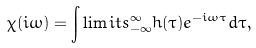<formula> <loc_0><loc_0><loc_500><loc_500>\chi ( i \omega ) = \int \lim i t s _ { - \infty } ^ { \infty } h ( \tau ) e ^ { - i \omega \tau } d \tau ,</formula> 